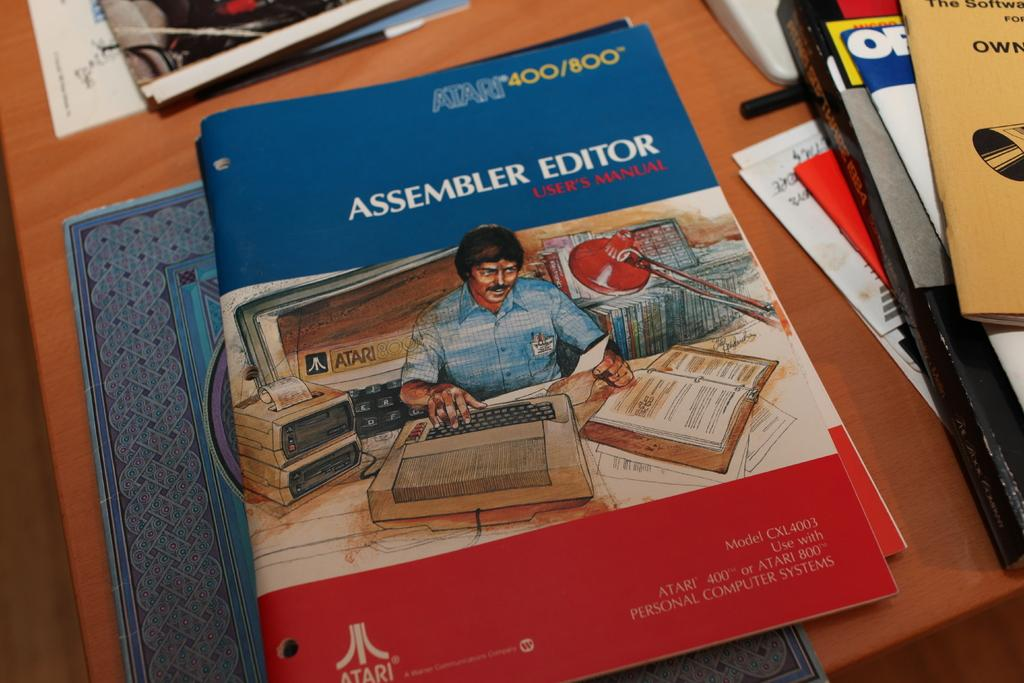<image>
Render a clear and concise summary of the photo. A book with a cartoon on its cover is titled Assembler Editor. 